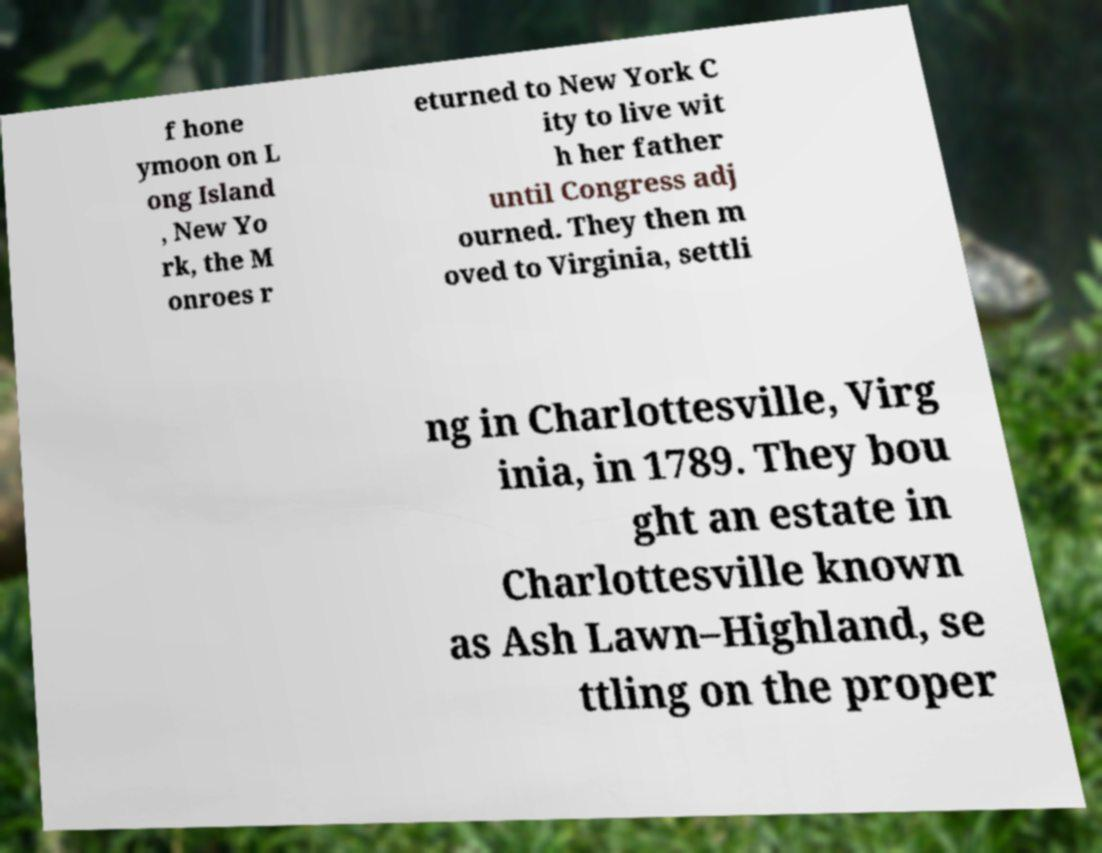Can you read and provide the text displayed in the image?This photo seems to have some interesting text. Can you extract and type it out for me? f hone ymoon on L ong Island , New Yo rk, the M onroes r eturned to New York C ity to live wit h her father until Congress adj ourned. They then m oved to Virginia, settli ng in Charlottesville, Virg inia, in 1789. They bou ght an estate in Charlottesville known as Ash Lawn–Highland, se ttling on the proper 